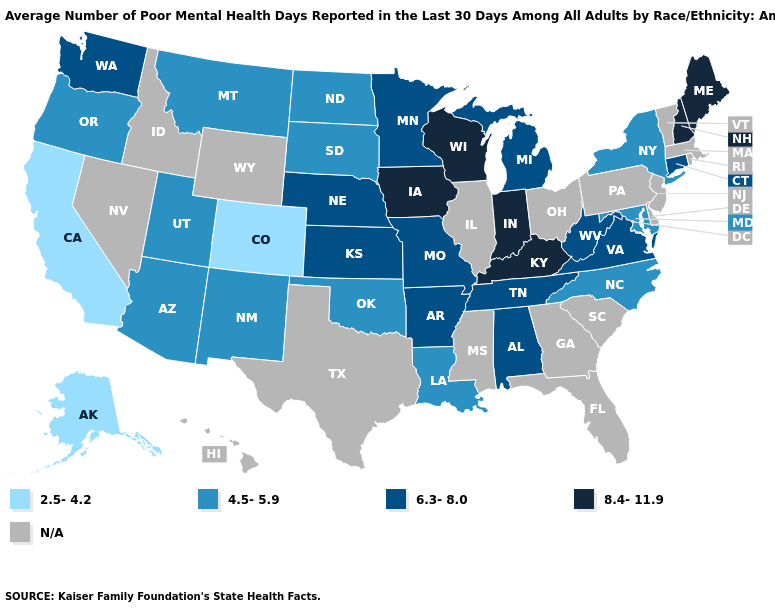How many symbols are there in the legend?
Short answer required. 5. Which states have the highest value in the USA?
Give a very brief answer. Indiana, Iowa, Kentucky, Maine, New Hampshire, Wisconsin. Among the states that border Wisconsin , which have the highest value?
Keep it brief. Iowa. Does the first symbol in the legend represent the smallest category?
Answer briefly. Yes. Among the states that border Wyoming , which have the highest value?
Quick response, please. Nebraska. Which states have the lowest value in the USA?
Write a very short answer. Alaska, California, Colorado. Which states have the lowest value in the USA?
Write a very short answer. Alaska, California, Colorado. How many symbols are there in the legend?
Be succinct. 5. What is the highest value in the USA?
Be succinct. 8.4-11.9. Is the legend a continuous bar?
Quick response, please. No. What is the lowest value in the Northeast?
Concise answer only. 4.5-5.9. Name the states that have a value in the range 8.4-11.9?
Answer briefly. Indiana, Iowa, Kentucky, Maine, New Hampshire, Wisconsin. What is the lowest value in the MidWest?
Concise answer only. 4.5-5.9. 